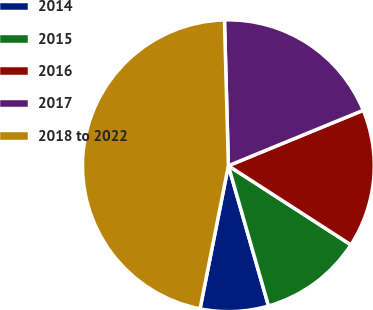Convert chart. <chart><loc_0><loc_0><loc_500><loc_500><pie_chart><fcel>2014<fcel>2015<fcel>2016<fcel>2017<fcel>2018 to 2022<nl><fcel>7.55%<fcel>11.44%<fcel>15.33%<fcel>19.22%<fcel>46.46%<nl></chart> 